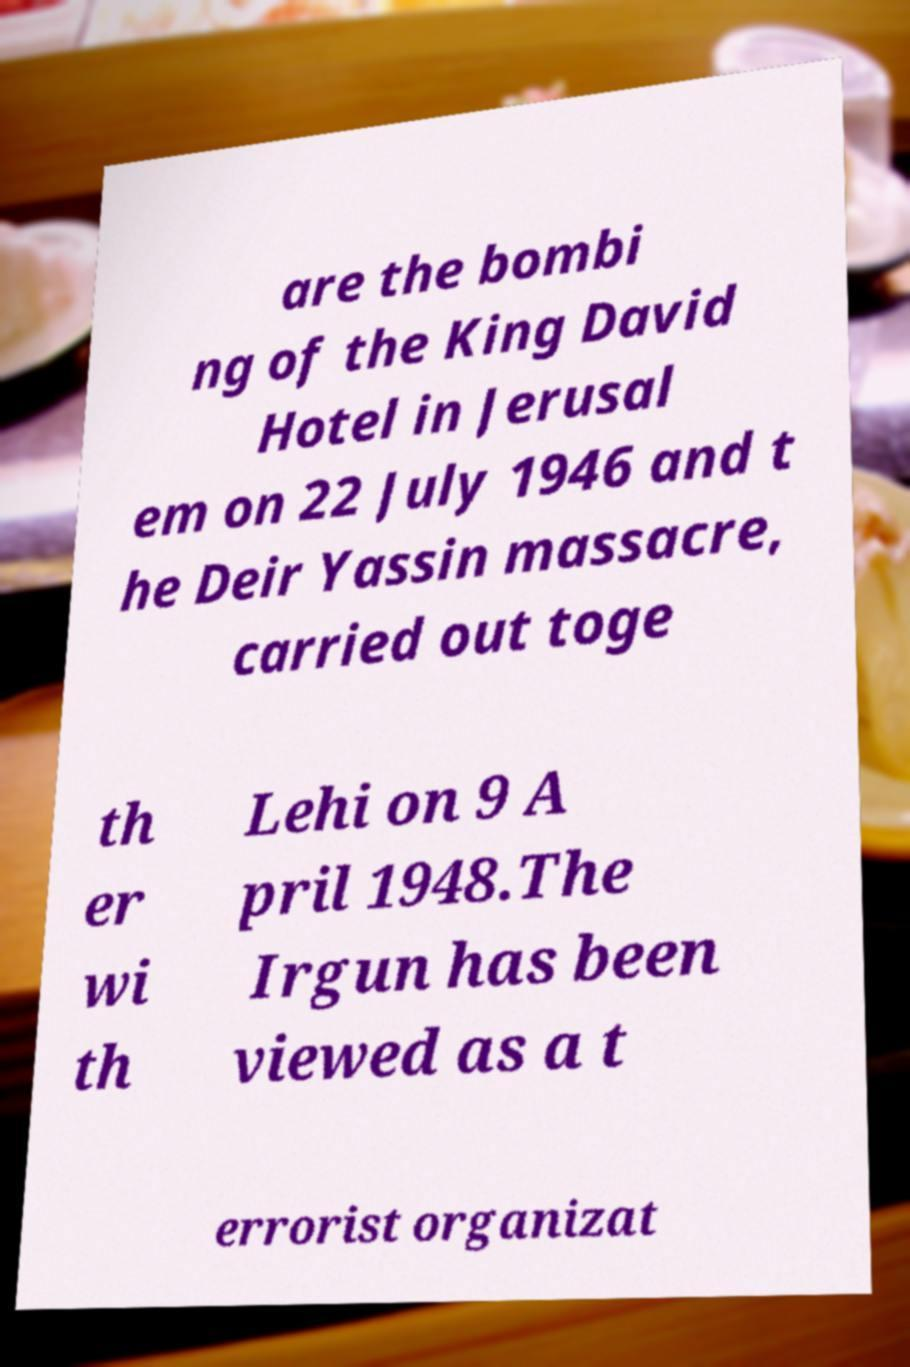Please read and relay the text visible in this image. What does it say? are the bombi ng of the King David Hotel in Jerusal em on 22 July 1946 and t he Deir Yassin massacre, carried out toge th er wi th Lehi on 9 A pril 1948.The Irgun has been viewed as a t errorist organizat 